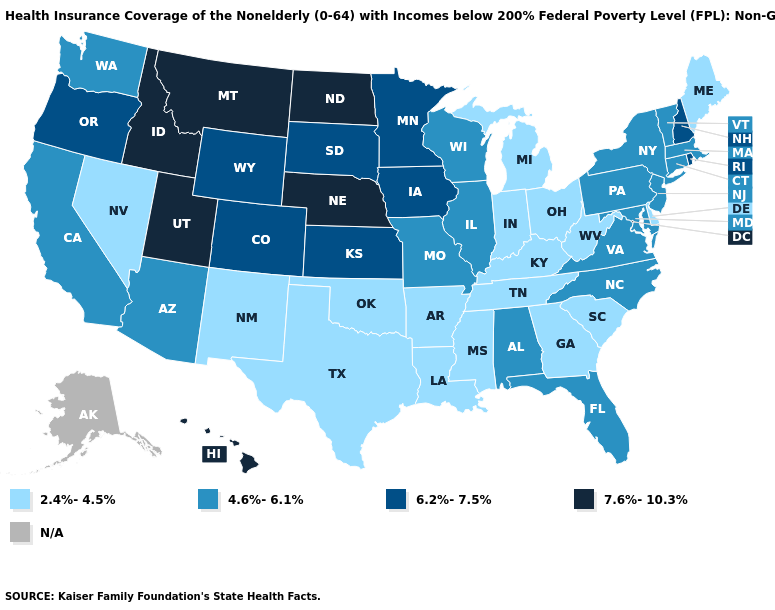Does the map have missing data?
Quick response, please. Yes. Among the states that border Vermont , which have the highest value?
Be succinct. New Hampshire. Among the states that border Florida , which have the highest value?
Be succinct. Alabama. What is the lowest value in states that border Maryland?
Concise answer only. 2.4%-4.5%. Name the states that have a value in the range 6.2%-7.5%?
Concise answer only. Colorado, Iowa, Kansas, Minnesota, New Hampshire, Oregon, Rhode Island, South Dakota, Wyoming. What is the highest value in the West ?
Write a very short answer. 7.6%-10.3%. What is the value of New Mexico?
Give a very brief answer. 2.4%-4.5%. What is the highest value in the USA?
Give a very brief answer. 7.6%-10.3%. Which states have the lowest value in the USA?
Concise answer only. Arkansas, Delaware, Georgia, Indiana, Kentucky, Louisiana, Maine, Michigan, Mississippi, Nevada, New Mexico, Ohio, Oklahoma, South Carolina, Tennessee, Texas, West Virginia. Does Vermont have the lowest value in the Northeast?
Keep it brief. No. What is the value of Hawaii?
Write a very short answer. 7.6%-10.3%. Name the states that have a value in the range 4.6%-6.1%?
Give a very brief answer. Alabama, Arizona, California, Connecticut, Florida, Illinois, Maryland, Massachusetts, Missouri, New Jersey, New York, North Carolina, Pennsylvania, Vermont, Virginia, Washington, Wisconsin. Does North Dakota have the highest value in the MidWest?
Keep it brief. Yes. 